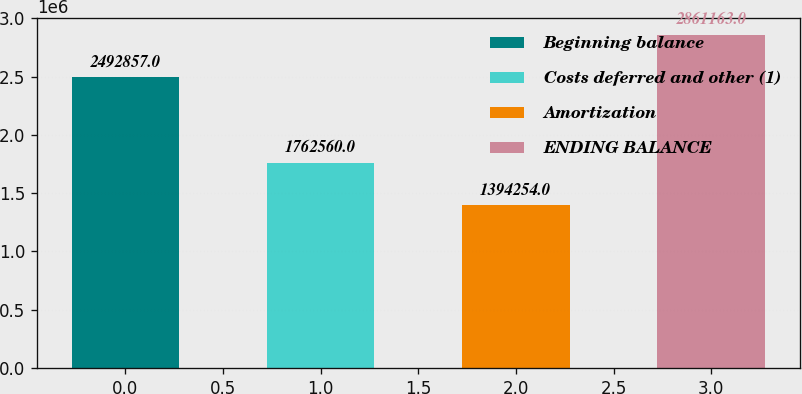Convert chart. <chart><loc_0><loc_0><loc_500><loc_500><bar_chart><fcel>Beginning balance<fcel>Costs deferred and other (1)<fcel>Amortization<fcel>ENDING BALANCE<nl><fcel>2.49286e+06<fcel>1.76256e+06<fcel>1.39425e+06<fcel>2.86116e+06<nl></chart> 